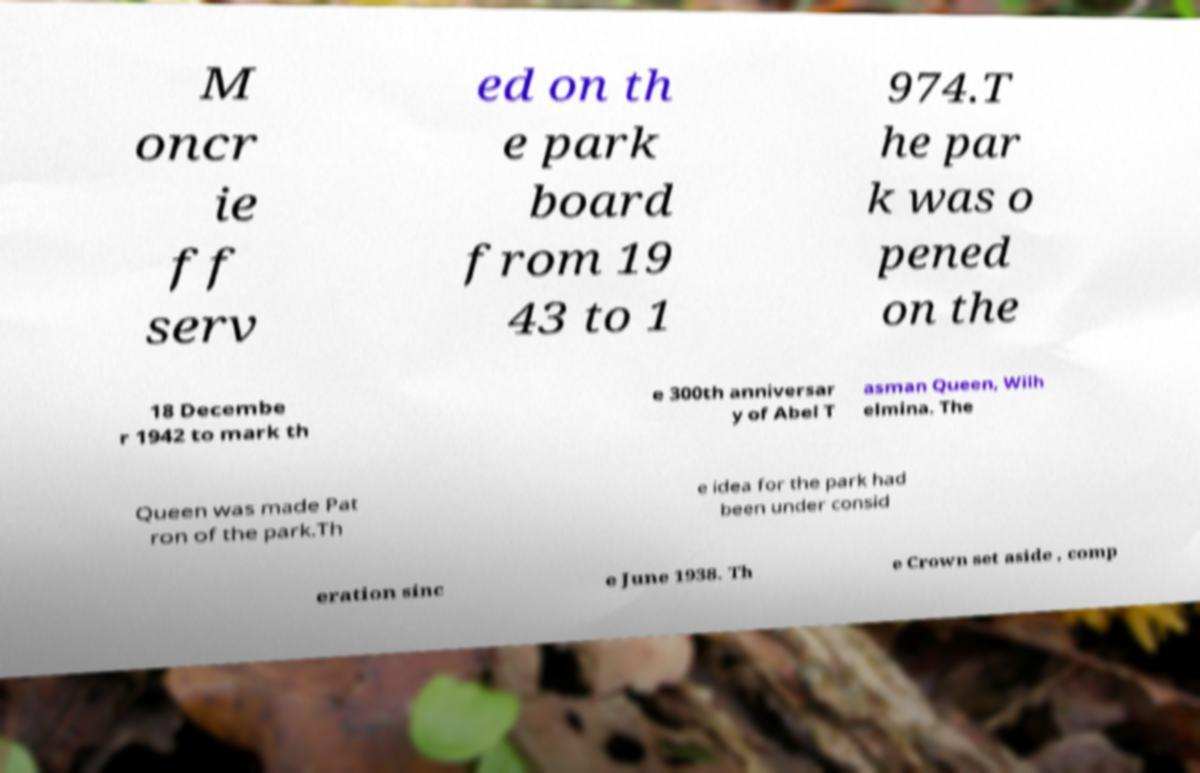What messages or text are displayed in this image? I need them in a readable, typed format. M oncr ie ff serv ed on th e park board from 19 43 to 1 974.T he par k was o pened on the 18 Decembe r 1942 to mark th e 300th anniversar y of Abel T asman Queen, Wilh elmina. The Queen was made Pat ron of the park.Th e idea for the park had been under consid eration sinc e June 1938. Th e Crown set aside , comp 